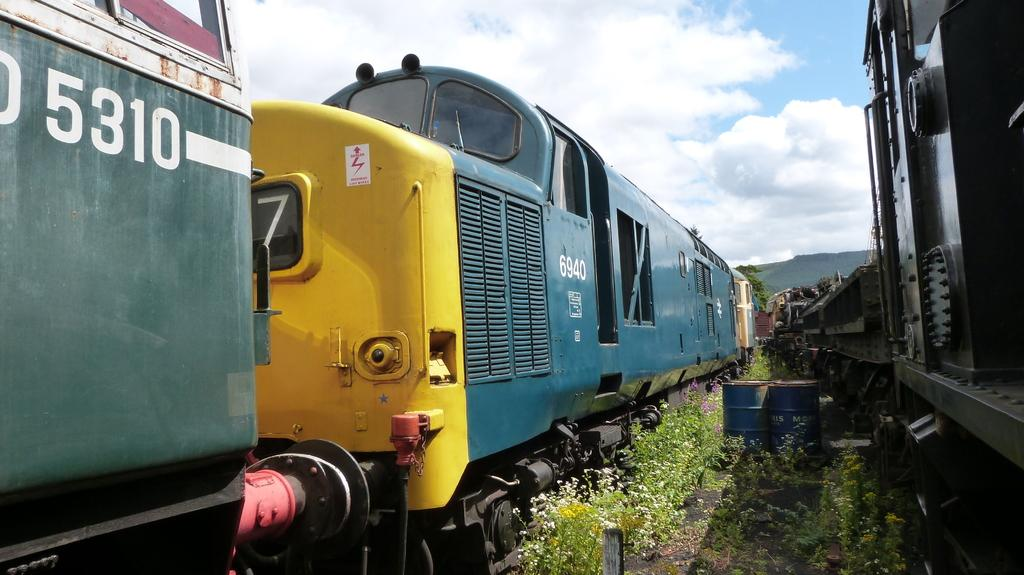What can be seen on the railway tracks in the image? There are trains standing on the railway tracks in the image. What objects are on the ground in the image? There are oil drums and plants on the ground in the image. How would you describe the sky in the image? The sky is cloudy in the image. Where is the receipt for the oil drums in the image? There is no receipt present in the image. What type of vacation is being taken by the church in the image? There is no church or vacation mentioned in the image. 